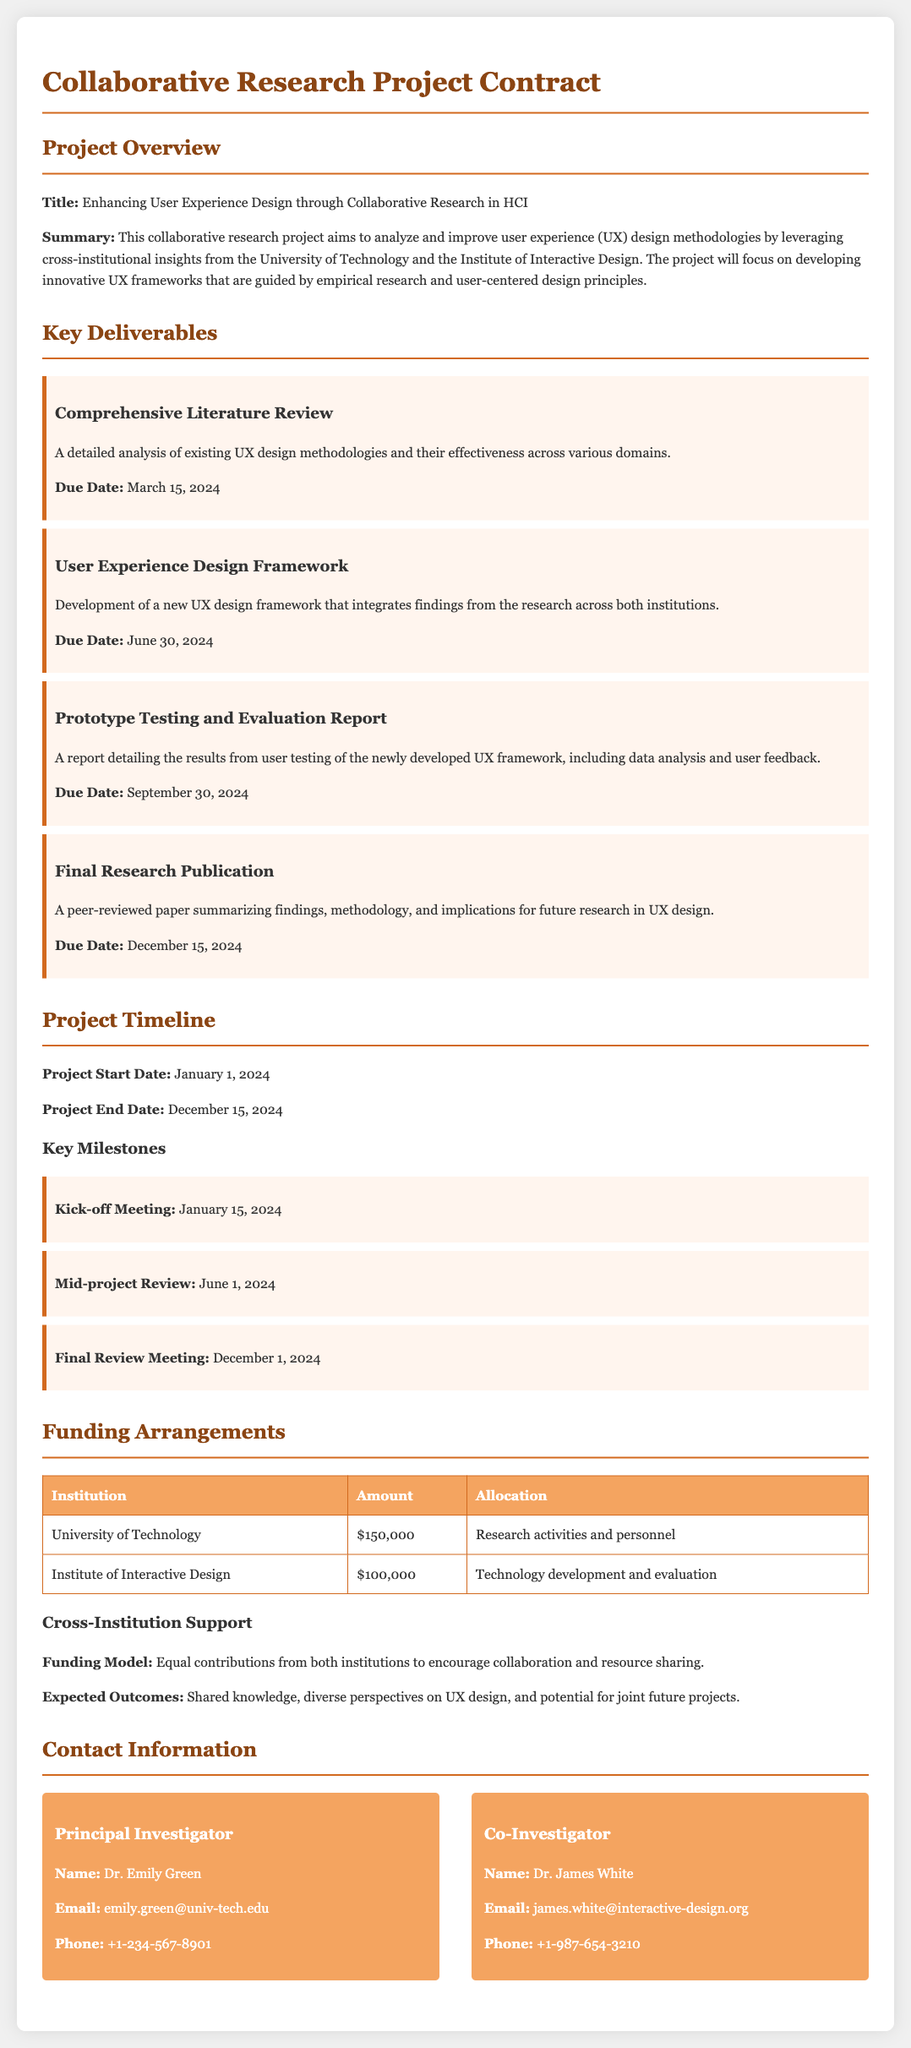what is the title of the project? The title is mentioned in the project overview section of the document.
Answer: Enhancing User Experience Design through Collaborative Research in HCI when is the due date for the Prototype Testing and Evaluation Report? The due date is provided in the key deliverables section of the document.
Answer: September 30, 2024 who is the Principal Investigator? The Principal Investigator's name is listed in the contact information section.
Answer: Dr. Emily Green what is the total funding amount from the University of Technology? The total funding amount is specified in the funding arrangements table of the document.
Answer: $150,000 what is the expected outcome of the funding model? The expected outcome is detailed under the cross-institution support section of the funding arrangements.
Answer: Shared knowledge, diverse perspectives on UX design, and potential for joint future projects when is the Project End Date? The project end date is provided in the project timeline section.
Answer: December 15, 2024 what is the due date for the Final Research Publication? This due date is specified in the key deliverables section.
Answer: December 15, 2024 what is the focus of the research project? The focus is mentioned in the summary of the project overview section.
Answer: Analyzing and improving user experience design methodologies what is the amount allocated for technology development and evaluation? This information can be found in the funding arrangements table.
Answer: $100,000 